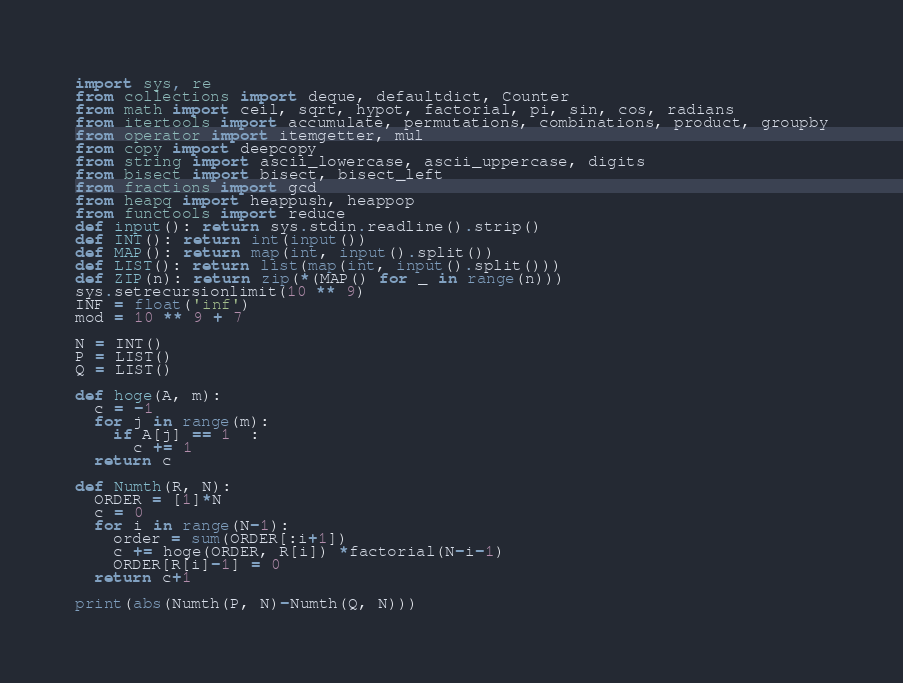<code> <loc_0><loc_0><loc_500><loc_500><_Python_>import sys, re
from collections import deque, defaultdict, Counter
from math import ceil, sqrt, hypot, factorial, pi, sin, cos, radians
from itertools import accumulate, permutations, combinations, product, groupby
from operator import itemgetter, mul
from copy import deepcopy
from string import ascii_lowercase, ascii_uppercase, digits
from bisect import bisect, bisect_left
from fractions import gcd
from heapq import heappush, heappop
from functools import reduce
def input(): return sys.stdin.readline().strip()
def INT(): return int(input())
def MAP(): return map(int, input().split())
def LIST(): return list(map(int, input().split()))
def ZIP(n): return zip(*(MAP() for _ in range(n)))
sys.setrecursionlimit(10 ** 9)
INF = float('inf')
mod = 10 ** 9 + 7

N = INT()
P = LIST()
Q = LIST()

def hoge(A, m):
  c = -1
  for j in range(m):
    if A[j] == 1  :
      c += 1   
  return c

def Numth(R, N):
  ORDER = [1]*N
  c = 0
  for i in range(N-1):
    order = sum(ORDER[:i+1])
    c += hoge(ORDER, R[i]) *factorial(N-i-1)
    ORDER[R[i]-1] = 0 
  return c+1

print(abs(Numth(P, N)-Numth(Q, N)))</code> 